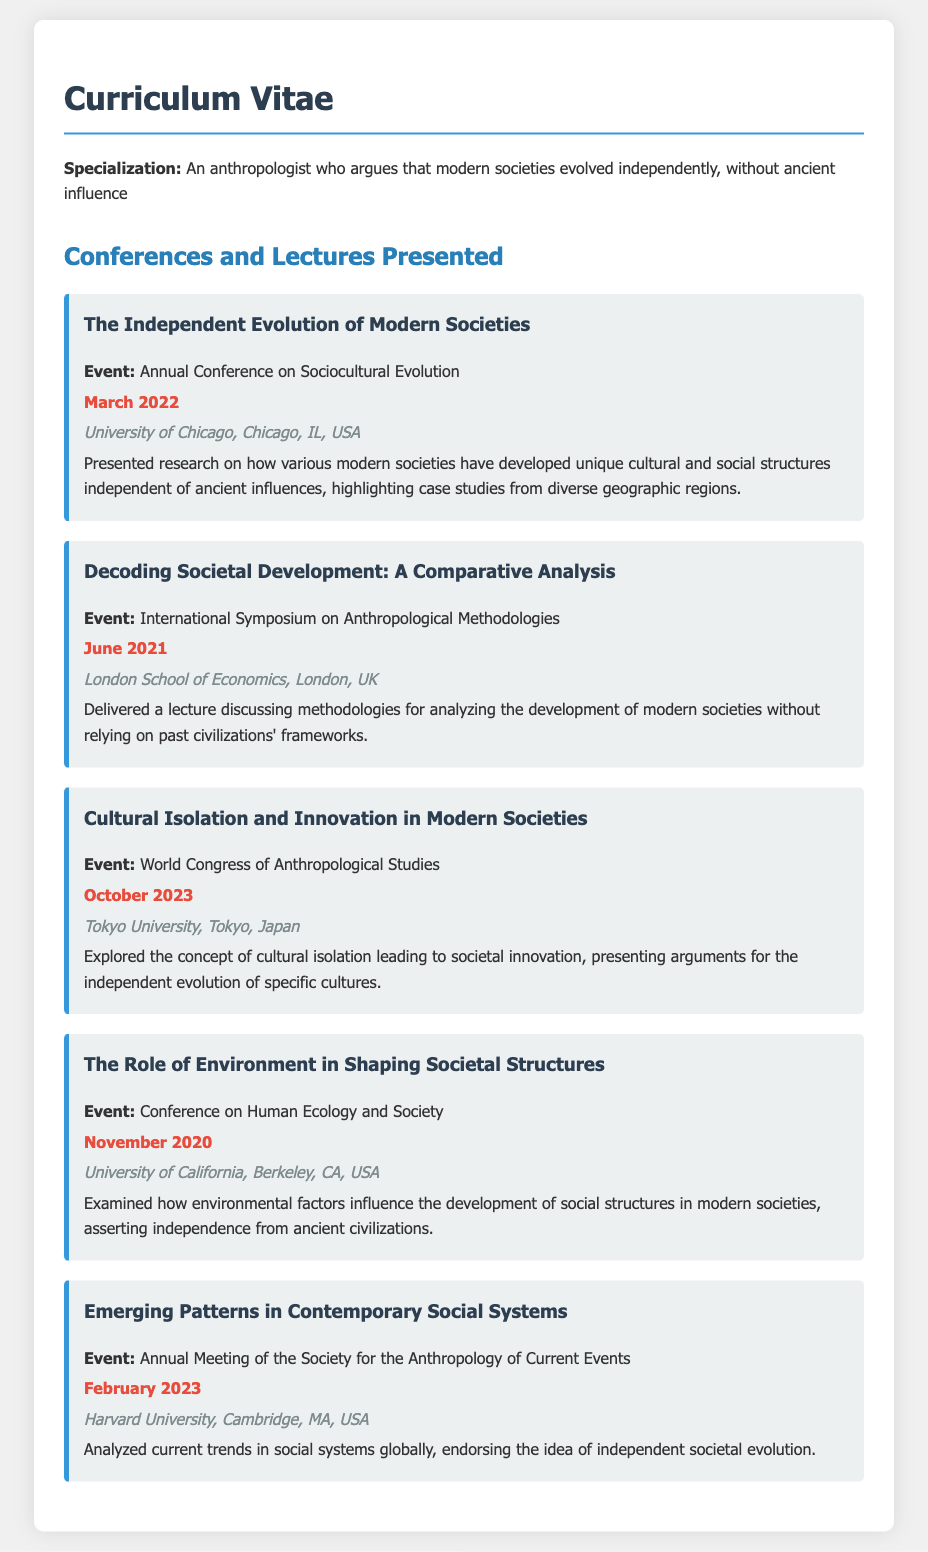what is the title of the first conference presented? The title of the first conference is presented in the document as "The Independent Evolution of Modern Societies".
Answer: The Independent Evolution of Modern Societies when was the lecture on "Decoding Societal Development: A Comparative Analysis" delivered? The date of the lecture can be found next to the title in the details of the conference. It was delivered in June 2021.
Answer: June 2021 where was the "Cultural Isolation and Innovation in Modern Societies" conference held? The location is clearly mentioned in the conference details, which states it took place at Tokyo University, Tokyo, Japan.
Answer: Tokyo University, Tokyo, Japan which event focused on methodologies for analyzing societal development? The event that focused on methodologies is documented as "International Symposium on Anthropological Methodologies".
Answer: International Symposium on Anthropological Methodologies how many conferences mentioned are related to independent societal evolution? Counting the conferences that specifically address independent societal evolution indicates there are four that relate directly to this theme.
Answer: Four what concept was explored in the "Cultural Isolation and Innovation in Modern Societies" conference? The document describes that this conference explored cultural isolation leading to societal innovation.
Answer: Cultural isolation leading to societal innovation what is emphasized in the "The Role of Environment in Shaping Societal Structures"? The emphasis of this conference is on how environmental factors influence social structures independently from ancient civilizations.
Answer: Environmental factors influence social structures independently which conference was held most recently? The most recent conference is the one dated October 2023, which is "Cultural Isolation and Innovation in Modern Societies".
Answer: Cultural Isolation and Innovation in Modern Societies who presented at the Annual Meeting of the Society for the Anthropology of Current Events? The document does not specifically name individuals, but it indicates that the individual associated with this CV presented there.
Answer: The individual associated with this CV 